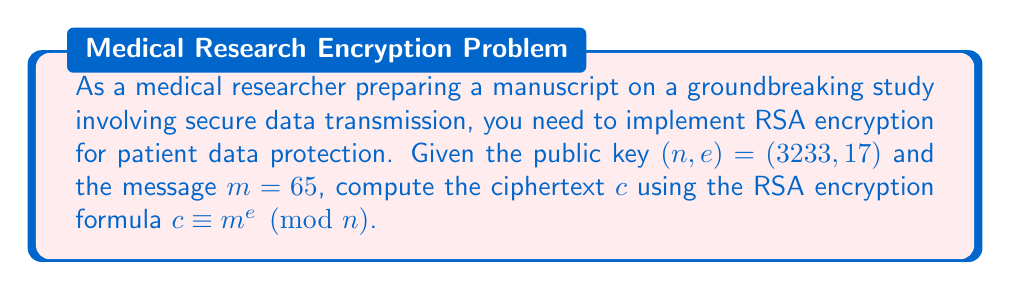Teach me how to tackle this problem. To compute the modular exponentiation for RSA encryption, we need to calculate $c \equiv m^e \pmod{n}$ where:

$m = 65$ (the message)
$e = 17$ (the public exponent)
$n = 3233$ (the modulus)

We can use the square-and-multiply algorithm to efficiently compute this large exponentiation:

1) Convert $e = 17$ to binary: $17_{10} = 10001_2$

2) Initialize: $result = 1$

3) For each bit in $e$ from left to right:
   a) Square the result: $result = result^2 \pmod{n}$
   b) If the bit is 1, multiply by $m$: $result = result \cdot m \pmod{n}$

Step-by-step calculation:

$$\begin{align*}
1: & \quad 1^2 \equiv 1 \pmod{3233} \\
   & \quad 1 \cdot 65 \equiv 65 \pmod{3233} \\
2: & \quad 65^2 \equiv 4225 \equiv 992 \pmod{3233} \\
3: & \quad 992^2 \equiv 984064 \equiv 2181 \pmod{3233} \\
4: & \quad 2181^2 \equiv 4756761 \equiv 2379 \pmod{3233} \\
5: & \quad 2379^2 \equiv 5659641 \equiv 2675 \pmod{3233} \\
   & \quad 2675 \cdot 65 \equiv 173875 \equiv 2990 \pmod{3233}
\end{align*}$$

Therefore, the ciphertext $c \equiv 65^{17} \equiv 2990 \pmod{3233}$.
Answer: $2990$ 